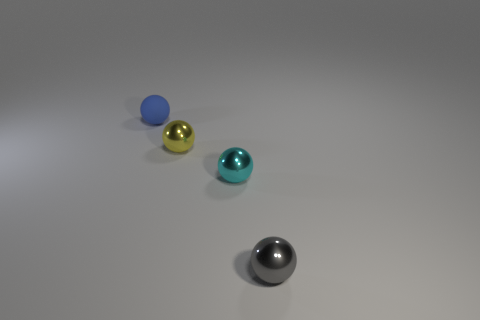Subtract all small yellow spheres. How many spheres are left? 3 Subtract all cyan balls. How many balls are left? 3 Subtract 2 balls. How many balls are left? 2 Add 4 brown metal cubes. How many objects exist? 8 Subtract 0 yellow cylinders. How many objects are left? 4 Subtract all yellow balls. Subtract all purple blocks. How many balls are left? 3 Subtract all cyan cubes. How many gray spheres are left? 1 Subtract all metal balls. Subtract all small green things. How many objects are left? 1 Add 4 tiny yellow spheres. How many tiny yellow spheres are left? 5 Add 3 small shiny balls. How many small shiny balls exist? 6 